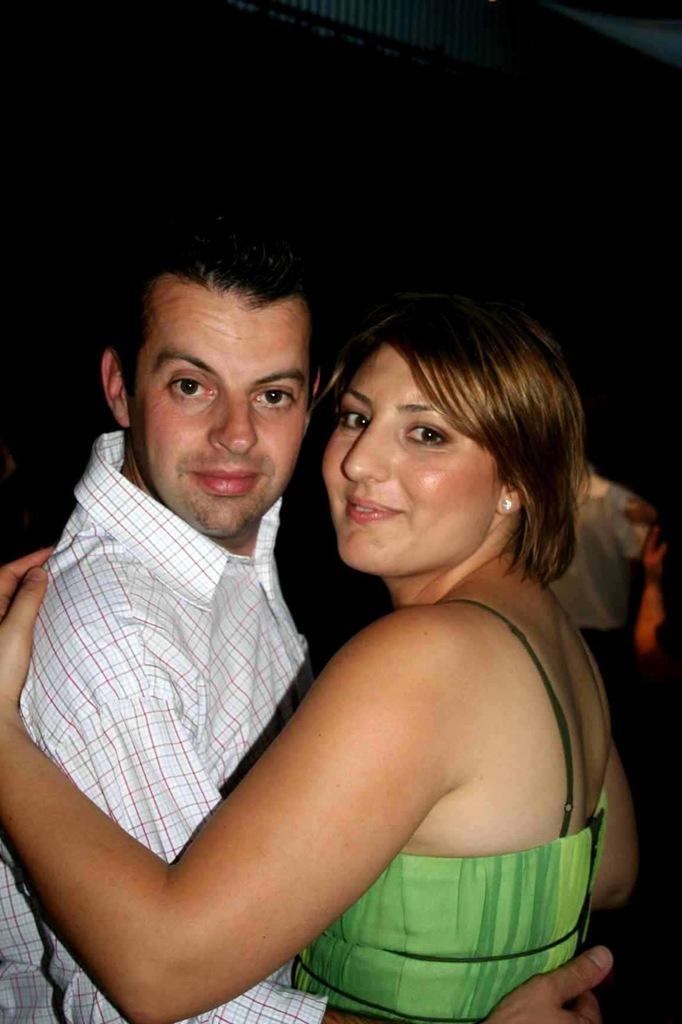Can you describe this image briefly? In this image, in the middle, we can see two people man and woman are holding each other. In the background, we can see a person and black color. 